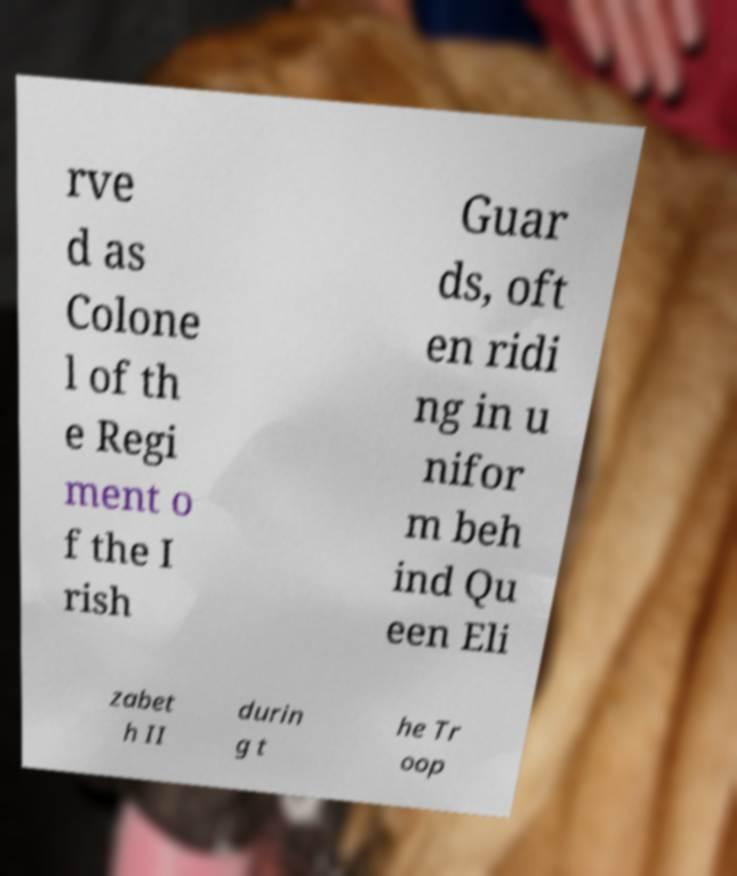Please read and relay the text visible in this image. What does it say? rve d as Colone l of th e Regi ment o f the I rish Guar ds, oft en ridi ng in u nifor m beh ind Qu een Eli zabet h II durin g t he Tr oop 